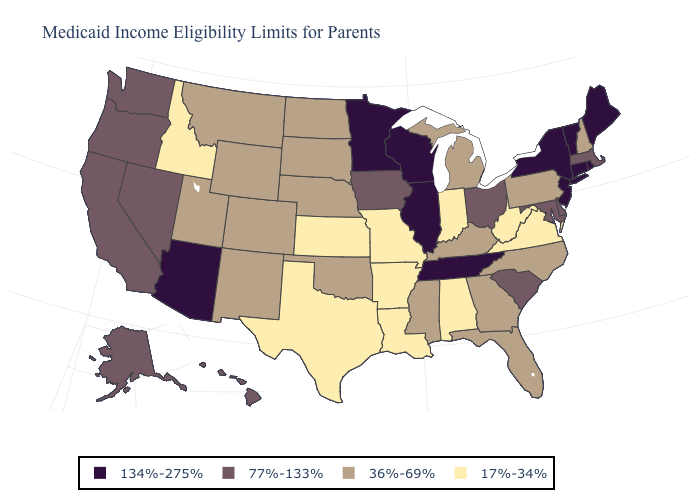Does Virginia have the same value as Idaho?
Short answer required. Yes. Name the states that have a value in the range 134%-275%?
Write a very short answer. Arizona, Connecticut, Illinois, Maine, Minnesota, New Jersey, New York, Rhode Island, Tennessee, Vermont, Wisconsin. What is the lowest value in the USA?
Short answer required. 17%-34%. What is the highest value in states that border Colorado?
Quick response, please. 134%-275%. How many symbols are there in the legend?
Concise answer only. 4. Among the states that border Delaware , which have the highest value?
Short answer required. New Jersey. Name the states that have a value in the range 36%-69%?
Keep it brief. Colorado, Florida, Georgia, Kentucky, Michigan, Mississippi, Montana, Nebraska, New Hampshire, New Mexico, North Carolina, North Dakota, Oklahoma, Pennsylvania, South Dakota, Utah, Wyoming. What is the value of Michigan?
Be succinct. 36%-69%. Does Arizona have the highest value in the USA?
Write a very short answer. Yes. Does Colorado have a higher value than West Virginia?
Concise answer only. Yes. Does Idaho have the highest value in the USA?
Short answer required. No. Does Louisiana have the lowest value in the USA?
Write a very short answer. Yes. What is the highest value in the USA?
Answer briefly. 134%-275%. What is the lowest value in states that border Utah?
Be succinct. 17%-34%. 